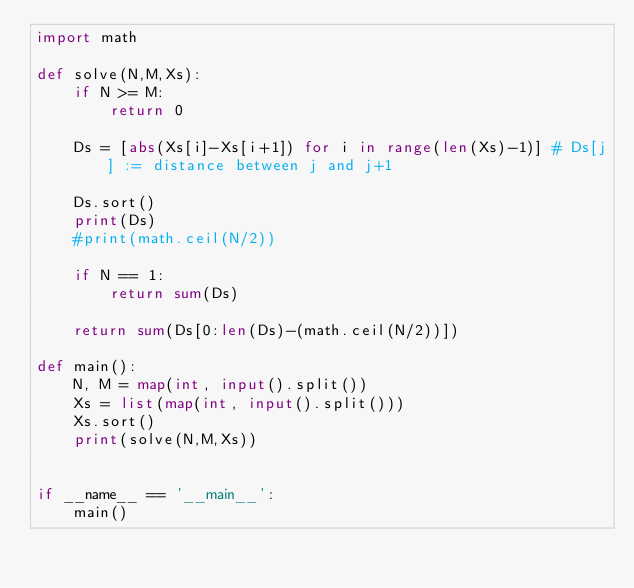<code> <loc_0><loc_0><loc_500><loc_500><_Python_>import math

def solve(N,M,Xs):
    if N >= M:
        return 0

    Ds = [abs(Xs[i]-Xs[i+1]) for i in range(len(Xs)-1)] # Ds[j] := distance between j and j+1

    Ds.sort()
    print(Ds)
    #print(math.ceil(N/2))

    if N == 1:
        return sum(Ds)

    return sum(Ds[0:len(Ds)-(math.ceil(N/2))])

def main():
    N, M = map(int, input().split())
    Xs = list(map(int, input().split()))
    Xs.sort()
    print(solve(N,M,Xs))


if __name__ == '__main__':
    main()</code> 